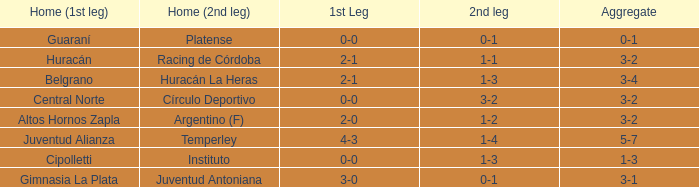Which team participated in the first leg at their home ground with a cumulative score of 3-4? Belgrano. 